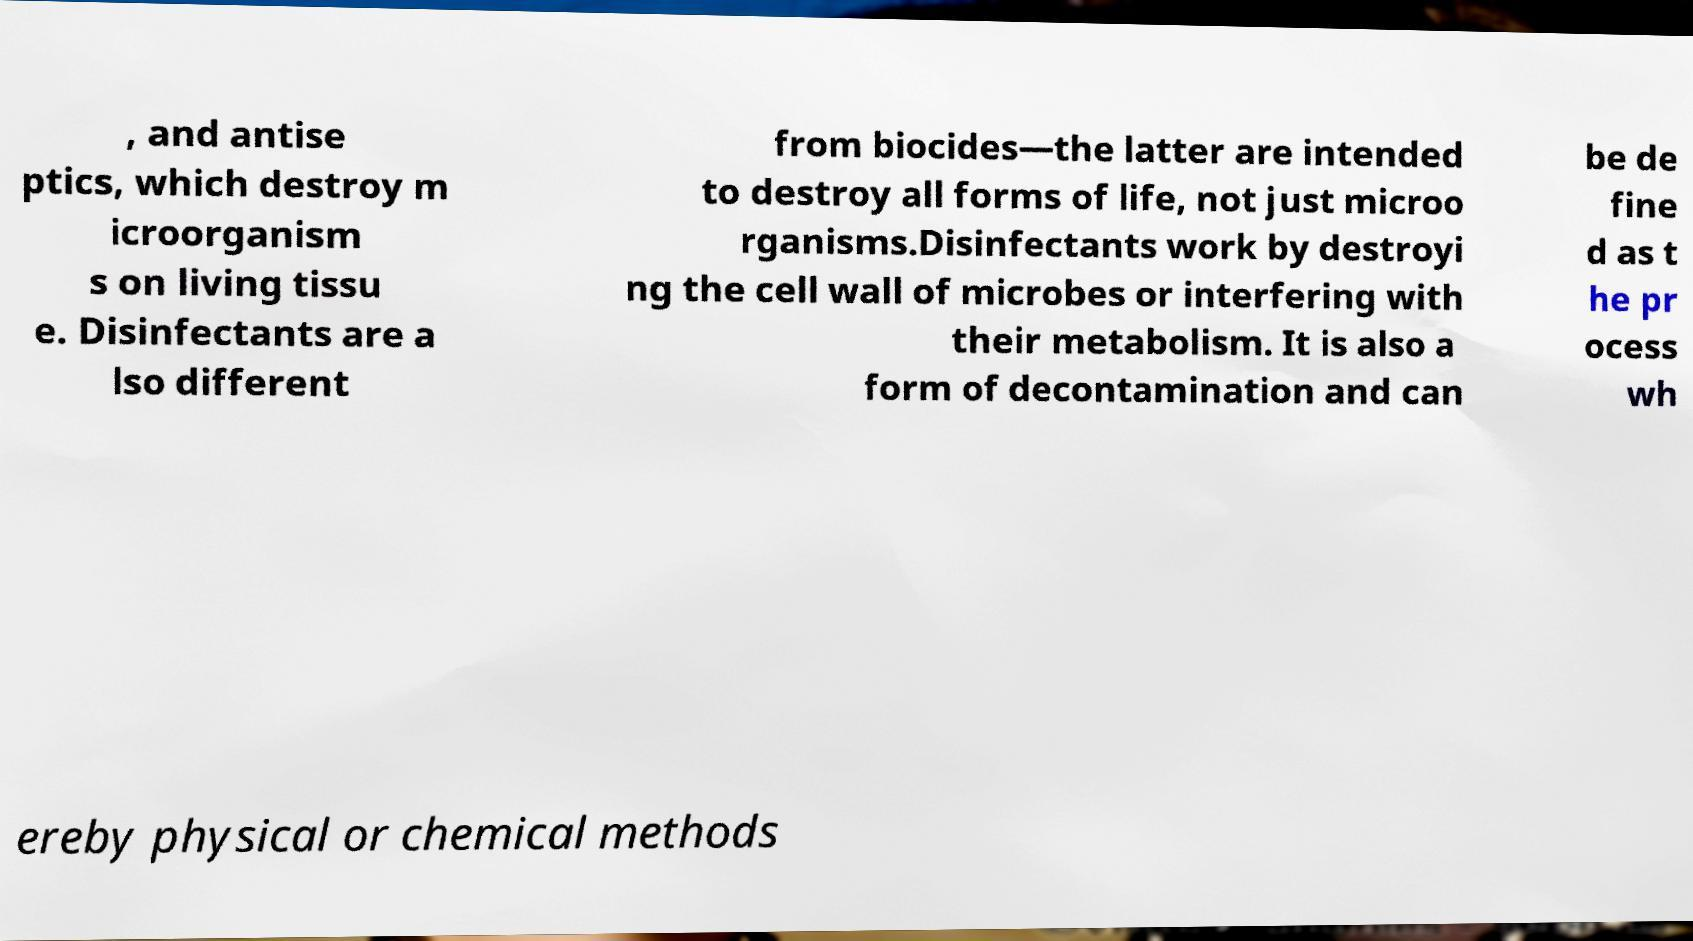Please identify and transcribe the text found in this image. , and antise ptics, which destroy m icroorganism s on living tissu e. Disinfectants are a lso different from biocides—the latter are intended to destroy all forms of life, not just microo rganisms.Disinfectants work by destroyi ng the cell wall of microbes or interfering with their metabolism. It is also a form of decontamination and can be de fine d as t he pr ocess wh ereby physical or chemical methods 